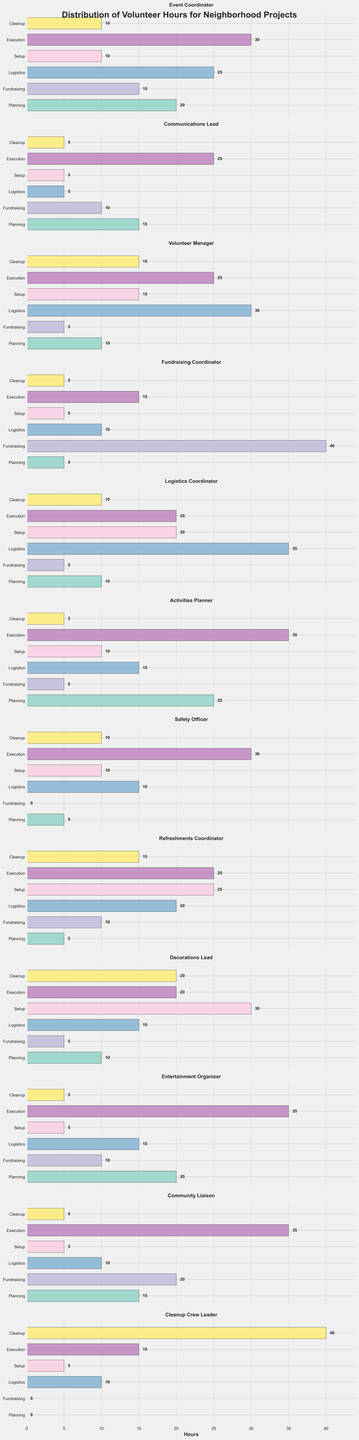What role has the highest number of hours in Fundraising? To figure out which role has the highest number of hours in Fundraising, look at the Fundraising bar for each role and compare their lengths.
Answer: Fundraising Coordinator Which role spent more hours on Execution compared to Setup? Compare the Execution and Setup hours for each role. Look for the roles where the Execution bar is longer than the Setup bar.
Answer: Communications Lead, Volunteer Manager, Safety Officer, Entertainment Organizer, Community Liaison What is the total number of hours for Logistics for all roles? Add the values for Logistics across all roles: 25 + 5 + 30 + 10 + 35 + 15 + 15 + 20 + 15 + 15 + 10 + 10.
Answer: 195 Which role has the least amount of hours in Planning? Compare all the bars for Planning and choose the shortest one.
Answer: Cleanup Crew Leader For Event Coordinator, do all categories have more than 10 hours? Check the number of hours for each category (Planning, Fundraising, Logistics, Setup, Execution, Cleanup) for the Event Coordinator and ensure each has more than 10 hours.
Answer: No What’s the difference in Execution hours between the Event Coordinator and the Volunteer Manager? Subtract the Execution hours of Volunteer Manager (25) from Event Coordinator (30).
Answer: 5 Which category has the most hours overall across all roles? Sum the hours for each category (Planning, Fundraising, Logistics, Setup, Execution, Cleanup) across all roles and compare the totals.
Answer: Execution How many roles spent exactly 20 hours in Planning? Check the hours spent on Planning for each role and count the number of roles that have exactly 20 hours.
Answer: 2 Which role shows the greatest diversity (highest range) in hours spent across different categories? Calculate the range (difference between maximum and minimum hours) for each role and check which has the highest range.
Answer: Volunteer Manager Is there any role that did not spend any hours in both Fundraising and Cleanup? Look for any role where both the Fundraising and Cleanup bars are at zero.
Answer: Cleanup Crew Leader 